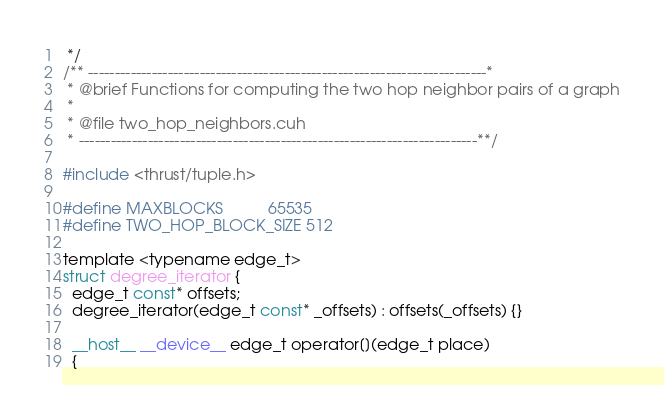Convert code to text. <code><loc_0><loc_0><loc_500><loc_500><_Cuda_> */
/** ---------------------------------------------------------------------------*
 * @brief Functions for computing the two hop neighbor pairs of a graph
 *
 * @file two_hop_neighbors.cuh
 * ---------------------------------------------------------------------------**/

#include <thrust/tuple.h>

#define MAXBLOCKS          65535
#define TWO_HOP_BLOCK_SIZE 512

template <typename edge_t>
struct degree_iterator {
  edge_t const* offsets;
  degree_iterator(edge_t const* _offsets) : offsets(_offsets) {}

  __host__ __device__ edge_t operator[](edge_t place)
  {</code> 